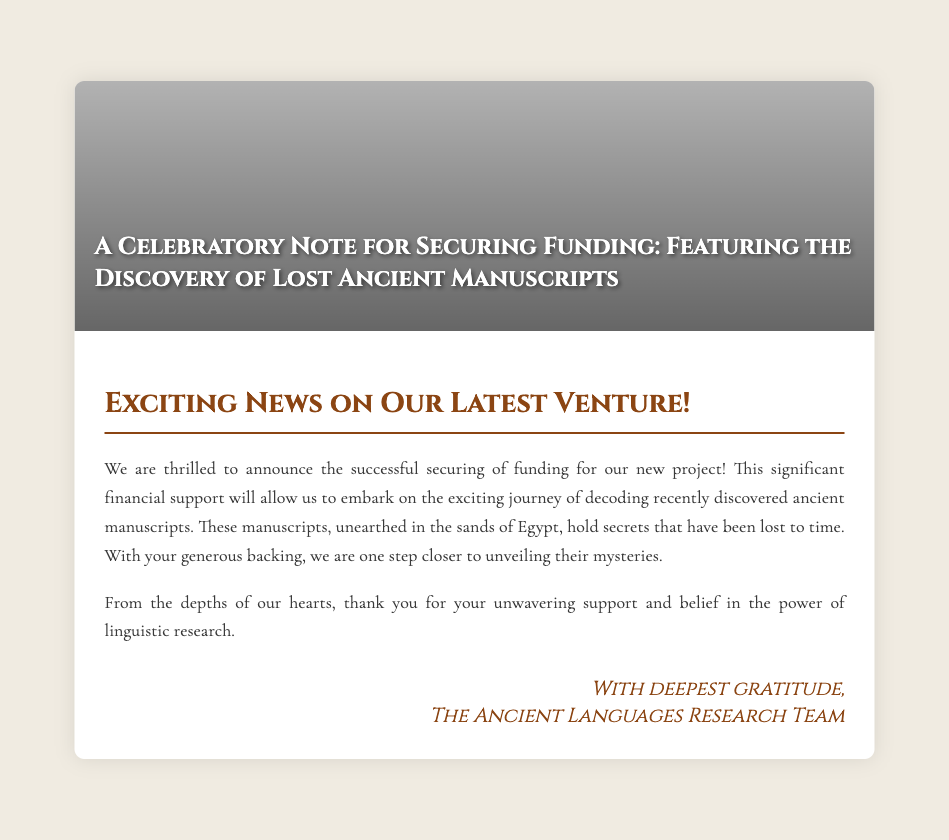What is the title of the card? The title is prominently displayed on the cover of the card, highlighting the purpose of the note.
Answer: A Celebratory Note for Securing Funding: Featuring the Discovery of Lost Ancient Manuscripts Where were the ancient manuscripts discovered? The document mentions the location where the manuscripts were unearthed.
Answer: Egypt What is the purpose of the secured funding? The funding will support a specific project outlined in the card.
Answer: Decoding recently discovered ancient manuscripts Who is expressing gratitude in the card? The sign-off reveals the organization or team thanking the donor for their support.
Answer: The Ancient Languages Research Team What sentiment is expressed towards the donor’s support? The card conveys a feeling of appreciation for the donor's contributions.
Answer: Unwavering support What type of document is this? This is categorized based on its structure and intent.
Answer: Greeting card How does the card describe the manuscripts? The description in the card indicates the significance and history of the manuscripts.
Answer: Hold secrets that have been lost to time What design element is featured on the cover? The visual aspect of the card’s cover contributes to its thematic representation.
Answer: Ancient script 